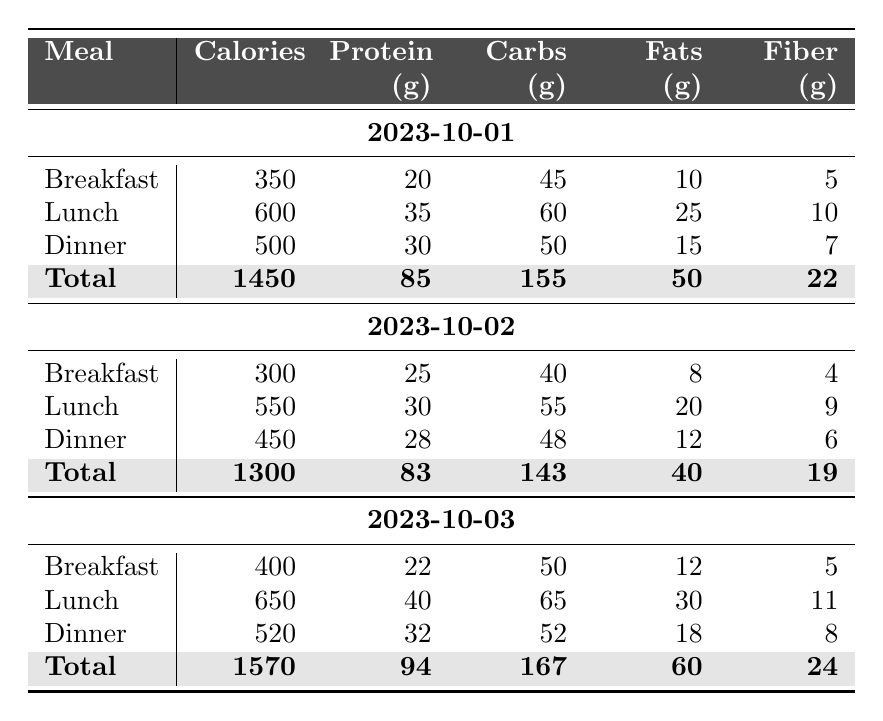What were the total calories consumed on October 1st? From the table, the total calories for October 1st can be found by looking at the row labeled "Total" under the date. The total is 1450 calories.
Answer: 1450 What is the protein intake for lunch on October 2nd? The lunch meal for October 2nd shows a protein intake of 30 grams.
Answer: 30 grams Which day had the highest total fiber intake? To find out which day had the highest total fiber intake, we look at the total fiber values for each day: October 1st (22g), October 2nd (19g), and October 3rd (24g). October 3rd has the highest total at 24 grams.
Answer: October 3rd What is the average calorie intake for all three days? To calculate the average, we first sum the total calories: 1450 + 1300 + 1570 = 4320. Then, we divide by the number of days, which is 3: 4320 / 3 = 1440.
Answer: 1440 Did any meal exceed 600 calories on October 2nd? Checking the calorie values for meals on October 2nd, breakfast is 300 calories, lunch is 550 calories, and dinner is 450 calories. None of these meals exceed 600 calories.
Answer: No What is the difference in total protein intake between October 1st and October 3rd? The total protein for October 1st is 85 grams, and for October 3rd, it is 94 grams. The difference is: 94 - 85 = 9 grams.
Answer: 9 grams On which meal of October 3rd was the highest fat intake recorded? The dinner meal on October 3rd has the highest fat intake recorded at 18 grams, compared to breakfast (12g) and lunch (30g).
Answer: Dinner What is the combined carbohydrate intake for breakfast and lunch on October 1st? For breakfast on October 1st, the carbohydrate intake is 45 grams, and for lunch, it is 60 grams. Adding these gives us: 45 + 60 = 105 grams.
Answer: 105 grams Is the total calorie intake higher on October 3rd than on October 2nd? On October 3rd, the total is 1570 calories, while on October 2nd it is 1300 calories. Since 1570 is greater than 1300, the statement is true.
Answer: Yes What meal on October 2nd had the least amount of fiber? The table shows that the breakfast on October 2nd had the least fiber with 4 grams, as lunch has 9 grams and dinner has 6 grams.
Answer: Breakfast 